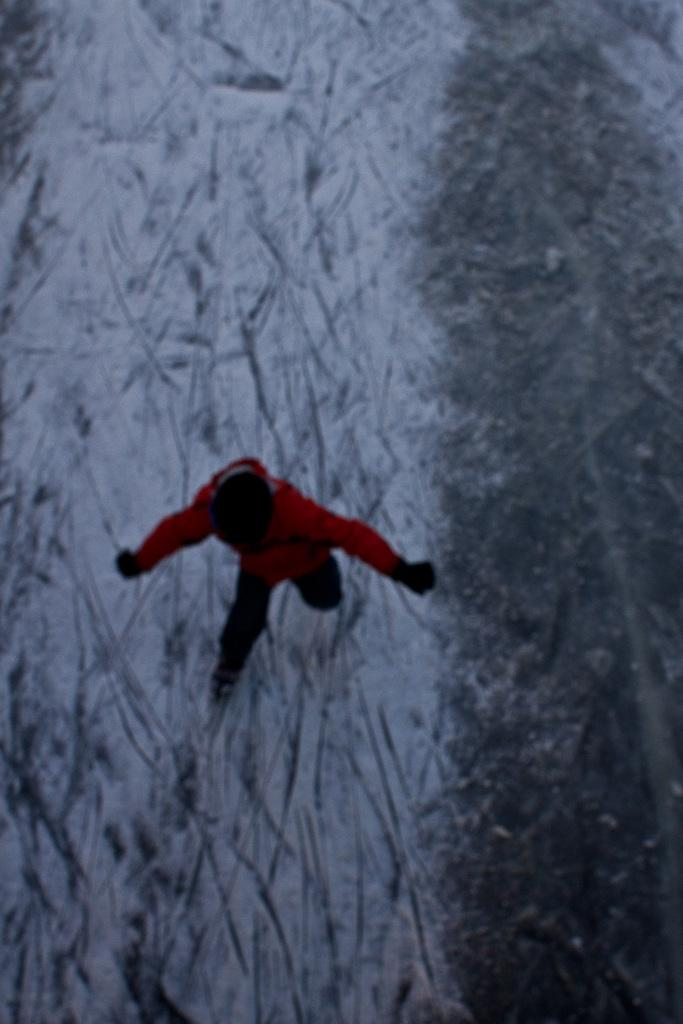What is the main subject of the image? There is a person in the image. What is the person wearing on their upper body? The person is wearing a red jacket. What type of headwear is the person wearing? The person is wearing a black cap. What type of terrain is the person running on? The person is running on snow. How many lizards can be seen in the image? There are no lizards present in the image. What type of agreement is the person holding in the image? There is no agreement visible in the image; the person is running on snow. 